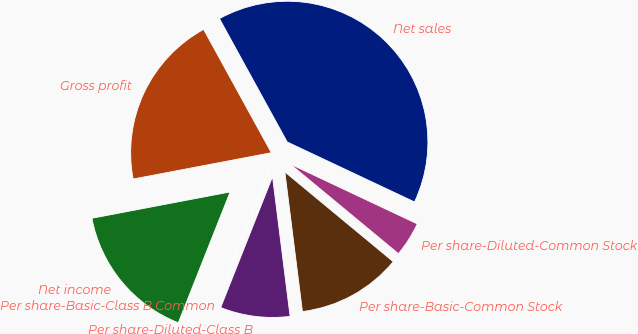<chart> <loc_0><loc_0><loc_500><loc_500><pie_chart><fcel>Net sales<fcel>Gross profit<fcel>Net income<fcel>Per share-Basic-Class B Common<fcel>Per share-Diluted-Class B<fcel>Per share-Basic-Common Stock<fcel>Per share-Diluted-Common Stock<nl><fcel>40.0%<fcel>20.0%<fcel>16.0%<fcel>0.0%<fcel>8.0%<fcel>12.0%<fcel>4.0%<nl></chart> 